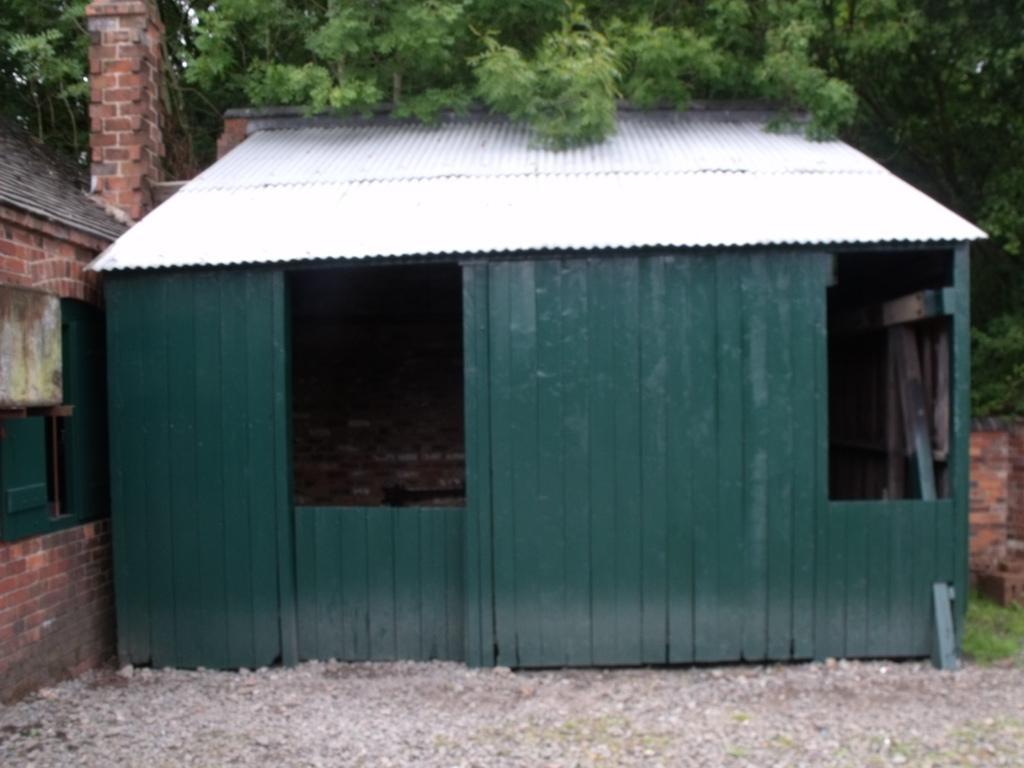Could you give a brief overview of what you see in this image? In this image we can see a shed with a roof. On the left side of the image we can see a house with a window. At the top of the image we can see a group of trees. 